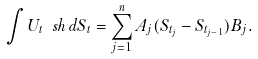Convert formula to latex. <formula><loc_0><loc_0><loc_500><loc_500>\int U _ { t } \ s h \, d S _ { t } = \sum _ { j = 1 } ^ { n } A _ { j } ( S _ { t _ { j } } - S _ { t _ { j - 1 } } ) B _ { j } .</formula> 